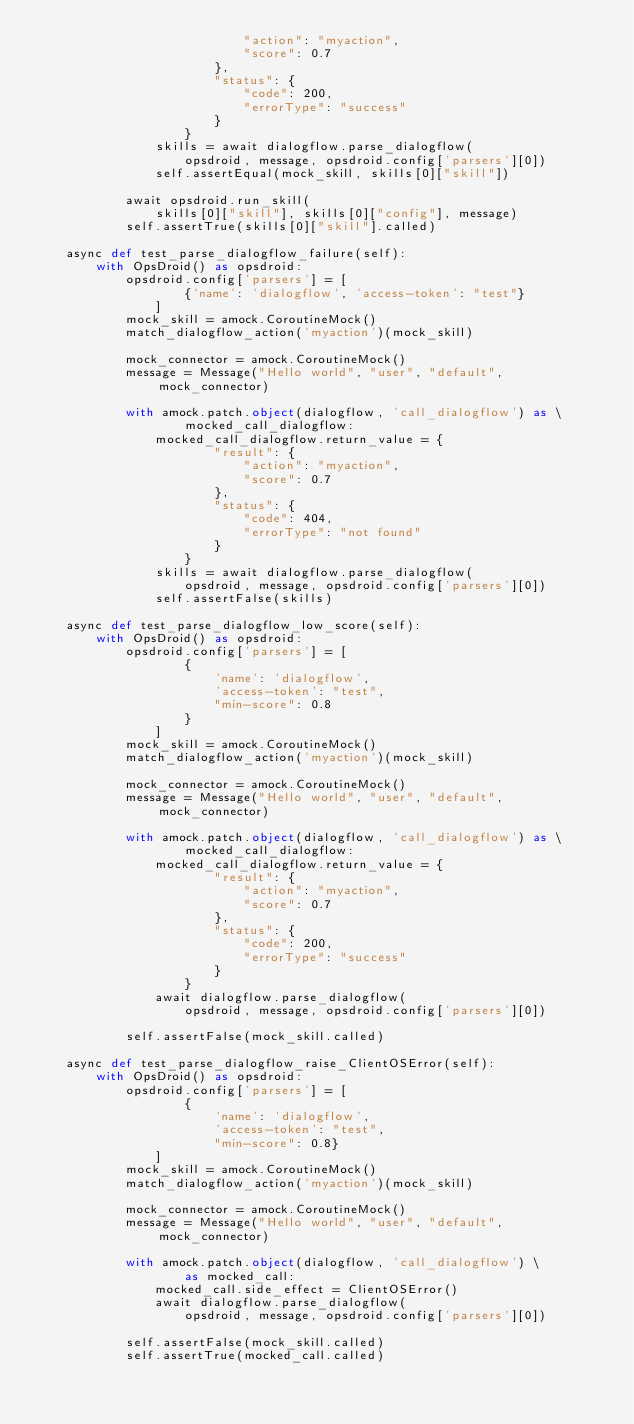<code> <loc_0><loc_0><loc_500><loc_500><_Python_>                            "action": "myaction",
                            "score": 0.7
                        },
                        "status": {
                            "code": 200,
                            "errorType": "success"
                        }
                    }
                skills = await dialogflow.parse_dialogflow(
                    opsdroid, message, opsdroid.config['parsers'][0])
                self.assertEqual(mock_skill, skills[0]["skill"])

            await opsdroid.run_skill(
                skills[0]["skill"], skills[0]["config"], message)
            self.assertTrue(skills[0]["skill"].called)

    async def test_parse_dialogflow_failure(self):
        with OpsDroid() as opsdroid:
            opsdroid.config['parsers'] = [
                    {'name': 'dialogflow', 'access-token': "test"}
                ]
            mock_skill = amock.CoroutineMock()
            match_dialogflow_action('myaction')(mock_skill)

            mock_connector = amock.CoroutineMock()
            message = Message("Hello world", "user", "default", mock_connector)

            with amock.patch.object(dialogflow, 'call_dialogflow') as \
                    mocked_call_dialogflow:
                mocked_call_dialogflow.return_value = {
                        "result": {
                            "action": "myaction",
                            "score": 0.7
                        },
                        "status": {
                            "code": 404,
                            "errorType": "not found"
                        }
                    }
                skills = await dialogflow.parse_dialogflow(
                    opsdroid, message, opsdroid.config['parsers'][0])
                self.assertFalse(skills)

    async def test_parse_dialogflow_low_score(self):
        with OpsDroid() as opsdroid:
            opsdroid.config['parsers'] = [
                    {
                        'name': 'dialogflow',
                        'access-token': "test",
                        "min-score": 0.8
                    }
                ]
            mock_skill = amock.CoroutineMock()
            match_dialogflow_action('myaction')(mock_skill)

            mock_connector = amock.CoroutineMock()
            message = Message("Hello world", "user", "default", mock_connector)

            with amock.patch.object(dialogflow, 'call_dialogflow') as \
                    mocked_call_dialogflow:
                mocked_call_dialogflow.return_value = {
                        "result": {
                            "action": "myaction",
                            "score": 0.7
                        },
                        "status": {
                            "code": 200,
                            "errorType": "success"
                        }
                    }
                await dialogflow.parse_dialogflow(
                    opsdroid, message, opsdroid.config['parsers'][0])

            self.assertFalse(mock_skill.called)

    async def test_parse_dialogflow_raise_ClientOSError(self):
        with OpsDroid() as opsdroid:
            opsdroid.config['parsers'] = [
                    {
                        'name': 'dialogflow',
                        'access-token': "test",
                        "min-score": 0.8}
                ]
            mock_skill = amock.CoroutineMock()
            match_dialogflow_action('myaction')(mock_skill)

            mock_connector = amock.CoroutineMock()
            message = Message("Hello world", "user", "default", mock_connector)

            with amock.patch.object(dialogflow, 'call_dialogflow') \
                    as mocked_call:
                mocked_call.side_effect = ClientOSError()
                await dialogflow.parse_dialogflow(
                    opsdroid, message, opsdroid.config['parsers'][0])

            self.assertFalse(mock_skill.called)
            self.assertTrue(mocked_call.called)
</code> 